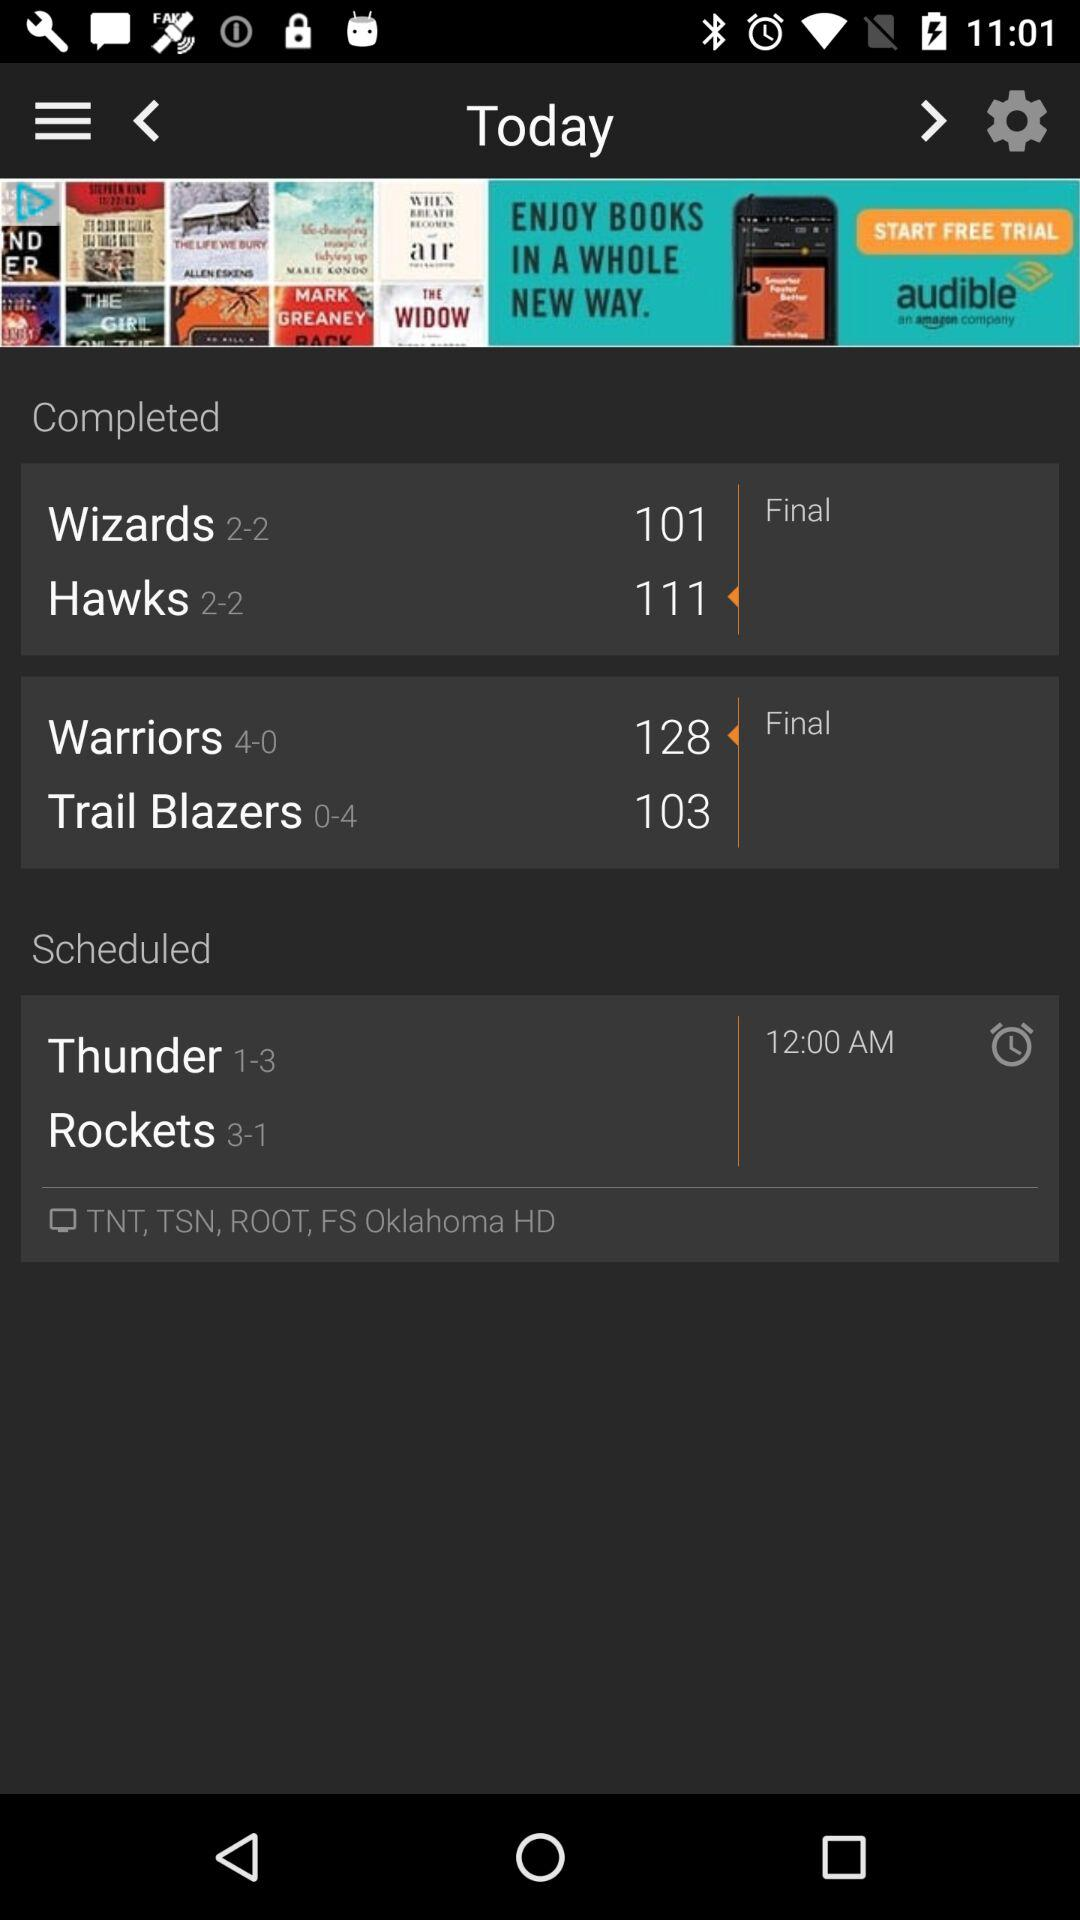What is the status mentioned?
When the provided information is insufficient, respond with <no answer>. <no answer> 